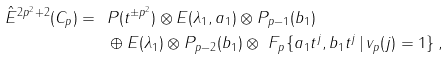<formula> <loc_0><loc_0><loc_500><loc_500>\hat { E } ^ { 2 p ^ { 2 } + 2 } ( C _ { p } ) = \ & P ( t ^ { \pm p ^ { 2 } } ) \otimes E ( \lambda _ { 1 } , a _ { 1 } ) \otimes P _ { p - 1 } ( b _ { 1 } ) \\ & \oplus E ( \lambda _ { 1 } ) \otimes P _ { p - 2 } ( b _ { 1 } ) \otimes \ F _ { p } \{ a _ { 1 } t ^ { j } , b _ { 1 } t ^ { j } \, | \, v _ { p } ( j ) = 1 \} \, ,</formula> 